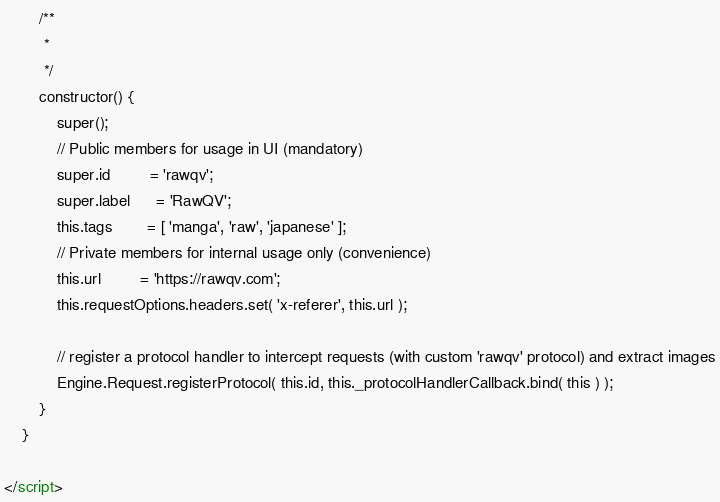<code> <loc_0><loc_0><loc_500><loc_500><_HTML_>
        /**
         *
         */
        constructor() {
            super();
            // Public members for usage in UI (mandatory)
            super.id         = 'rawqv';
            super.label      = 'RawQV';
            this.tags        = [ 'manga', 'raw', 'japanese' ];
            // Private members for internal usage only (convenience)
            this.url         = 'https://rawqv.com';
            this.requestOptions.headers.set( 'x-referer', this.url );

            // register a protocol handler to intercept requests (with custom 'rawqv' protocol) and extract images
            Engine.Request.registerProtocol( this.id, this._protocolHandlerCallback.bind( this ) );
        }
    }

</script></code> 